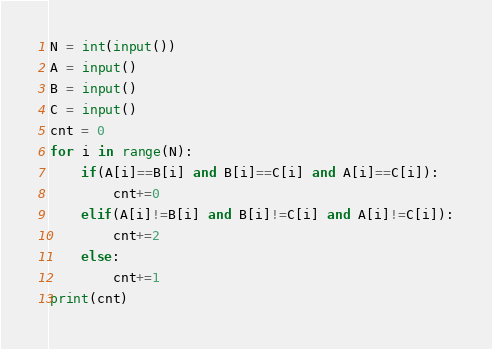<code> <loc_0><loc_0><loc_500><loc_500><_Python_>N = int(input())
A = input()
B = input()
C = input()
cnt = 0
for i in range(N):
    if(A[i]==B[i] and B[i]==C[i] and A[i]==C[i]):
        cnt+=0
    elif(A[i]!=B[i] and B[i]!=C[i] and A[i]!=C[i]):
        cnt+=2
    else:
        cnt+=1
print(cnt)
</code> 